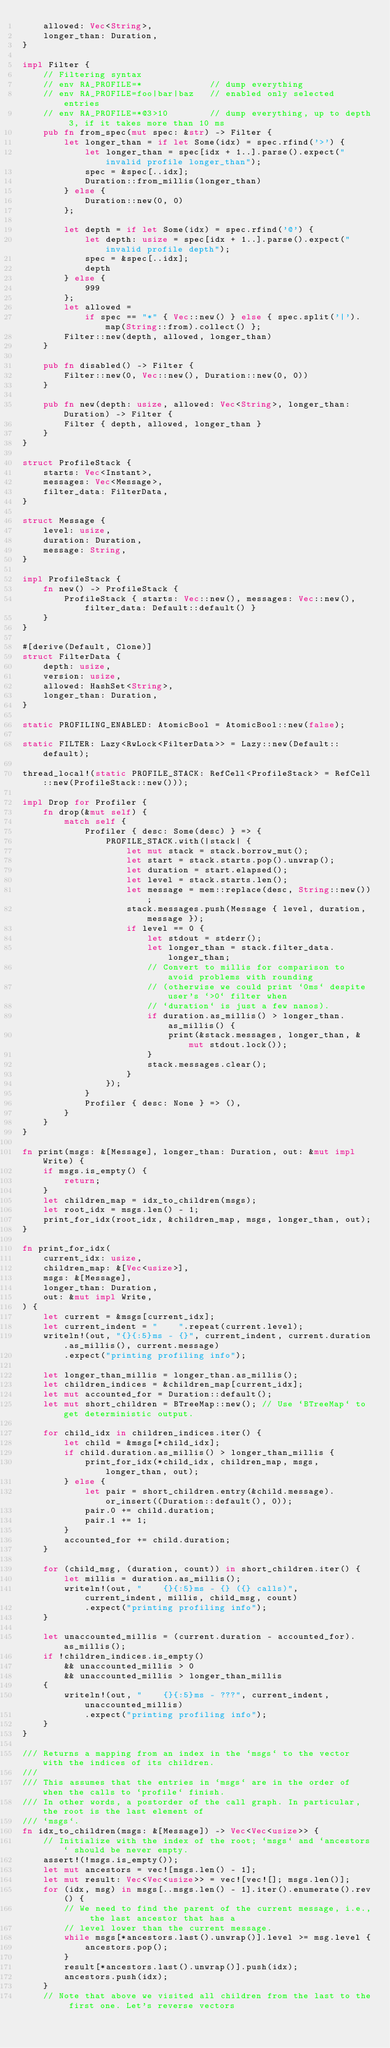Convert code to text. <code><loc_0><loc_0><loc_500><loc_500><_Rust_>    allowed: Vec<String>,
    longer_than: Duration,
}

impl Filter {
    // Filtering syntax
    // env RA_PROFILE=*             // dump everything
    // env RA_PROFILE=foo|bar|baz   // enabled only selected entries
    // env RA_PROFILE=*@3>10        // dump everything, up to depth 3, if it takes more than 10 ms
    pub fn from_spec(mut spec: &str) -> Filter {
        let longer_than = if let Some(idx) = spec.rfind('>') {
            let longer_than = spec[idx + 1..].parse().expect("invalid profile longer_than");
            spec = &spec[..idx];
            Duration::from_millis(longer_than)
        } else {
            Duration::new(0, 0)
        };

        let depth = if let Some(idx) = spec.rfind('@') {
            let depth: usize = spec[idx + 1..].parse().expect("invalid profile depth");
            spec = &spec[..idx];
            depth
        } else {
            999
        };
        let allowed =
            if spec == "*" { Vec::new() } else { spec.split('|').map(String::from).collect() };
        Filter::new(depth, allowed, longer_than)
    }

    pub fn disabled() -> Filter {
        Filter::new(0, Vec::new(), Duration::new(0, 0))
    }

    pub fn new(depth: usize, allowed: Vec<String>, longer_than: Duration) -> Filter {
        Filter { depth, allowed, longer_than }
    }
}

struct ProfileStack {
    starts: Vec<Instant>,
    messages: Vec<Message>,
    filter_data: FilterData,
}

struct Message {
    level: usize,
    duration: Duration,
    message: String,
}

impl ProfileStack {
    fn new() -> ProfileStack {
        ProfileStack { starts: Vec::new(), messages: Vec::new(), filter_data: Default::default() }
    }
}

#[derive(Default, Clone)]
struct FilterData {
    depth: usize,
    version: usize,
    allowed: HashSet<String>,
    longer_than: Duration,
}

static PROFILING_ENABLED: AtomicBool = AtomicBool::new(false);

static FILTER: Lazy<RwLock<FilterData>> = Lazy::new(Default::default);

thread_local!(static PROFILE_STACK: RefCell<ProfileStack> = RefCell::new(ProfileStack::new()));

impl Drop for Profiler {
    fn drop(&mut self) {
        match self {
            Profiler { desc: Some(desc) } => {
                PROFILE_STACK.with(|stack| {
                    let mut stack = stack.borrow_mut();
                    let start = stack.starts.pop().unwrap();
                    let duration = start.elapsed();
                    let level = stack.starts.len();
                    let message = mem::replace(desc, String::new());
                    stack.messages.push(Message { level, duration, message });
                    if level == 0 {
                        let stdout = stderr();
                        let longer_than = stack.filter_data.longer_than;
                        // Convert to millis for comparison to avoid problems with rounding
                        // (otherwise we could print `0ms` despite user's `>0` filter when
                        // `duration` is just a few nanos).
                        if duration.as_millis() > longer_than.as_millis() {
                            print(&stack.messages, longer_than, &mut stdout.lock());
                        }
                        stack.messages.clear();
                    }
                });
            }
            Profiler { desc: None } => (),
        }
    }
}

fn print(msgs: &[Message], longer_than: Duration, out: &mut impl Write) {
    if msgs.is_empty() {
        return;
    }
    let children_map = idx_to_children(msgs);
    let root_idx = msgs.len() - 1;
    print_for_idx(root_idx, &children_map, msgs, longer_than, out);
}

fn print_for_idx(
    current_idx: usize,
    children_map: &[Vec<usize>],
    msgs: &[Message],
    longer_than: Duration,
    out: &mut impl Write,
) {
    let current = &msgs[current_idx];
    let current_indent = "    ".repeat(current.level);
    writeln!(out, "{}{:5}ms - {}", current_indent, current.duration.as_millis(), current.message)
        .expect("printing profiling info");

    let longer_than_millis = longer_than.as_millis();
    let children_indices = &children_map[current_idx];
    let mut accounted_for = Duration::default();
    let mut short_children = BTreeMap::new(); // Use `BTreeMap` to get deterministic output.

    for child_idx in children_indices.iter() {
        let child = &msgs[*child_idx];
        if child.duration.as_millis() > longer_than_millis {
            print_for_idx(*child_idx, children_map, msgs, longer_than, out);
        } else {
            let pair = short_children.entry(&child.message).or_insert((Duration::default(), 0));
            pair.0 += child.duration;
            pair.1 += 1;
        }
        accounted_for += child.duration;
    }

    for (child_msg, (duration, count)) in short_children.iter() {
        let millis = duration.as_millis();
        writeln!(out, "    {}{:5}ms - {} ({} calls)", current_indent, millis, child_msg, count)
            .expect("printing profiling info");
    }

    let unaccounted_millis = (current.duration - accounted_for).as_millis();
    if !children_indices.is_empty()
        && unaccounted_millis > 0
        && unaccounted_millis > longer_than_millis
    {
        writeln!(out, "    {}{:5}ms - ???", current_indent, unaccounted_millis)
            .expect("printing profiling info");
    }
}

/// Returns a mapping from an index in the `msgs` to the vector with the indices of its children.
///
/// This assumes that the entries in `msgs` are in the order of when the calls to `profile` finish.
/// In other words, a postorder of the call graph. In particular, the root is the last element of
/// `msgs`.
fn idx_to_children(msgs: &[Message]) -> Vec<Vec<usize>> {
    // Initialize with the index of the root; `msgs` and `ancestors` should be never empty.
    assert!(!msgs.is_empty());
    let mut ancestors = vec![msgs.len() - 1];
    let mut result: Vec<Vec<usize>> = vec![vec![]; msgs.len()];
    for (idx, msg) in msgs[..msgs.len() - 1].iter().enumerate().rev() {
        // We need to find the parent of the current message, i.e., the last ancestor that has a
        // level lower than the current message.
        while msgs[*ancestors.last().unwrap()].level >= msg.level {
            ancestors.pop();
        }
        result[*ancestors.last().unwrap()].push(idx);
        ancestors.push(idx);
    }
    // Note that above we visited all children from the last to the first one. Let's reverse vectors</code> 